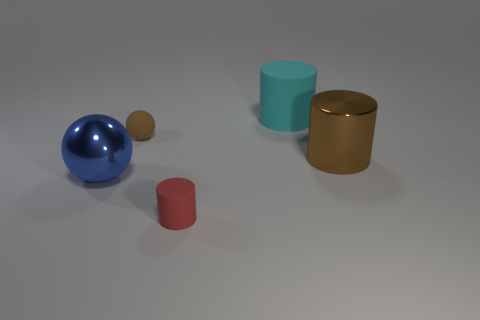There is a big metallic thing in front of the thing that is on the right side of the big matte object; what is its shape?
Offer a terse response. Sphere. How many things are big brown metallic things or things that are behind the small rubber cylinder?
Your answer should be very brief. 4. What number of other things are there of the same color as the large shiny cylinder?
Keep it short and to the point. 1. How many green objects are cylinders or tiny metal cubes?
Give a very brief answer. 0. There is a matte cylinder that is left of the big object that is behind the large brown thing; are there any large rubber cylinders that are left of it?
Your answer should be very brief. No. Is the metallic cylinder the same color as the matte sphere?
Your answer should be compact. Yes. What is the color of the cylinder in front of the shiny object on the left side of the brown ball?
Offer a very short reply. Red. What number of large objects are brown objects or spheres?
Your response must be concise. 2. The large thing that is both on the right side of the rubber sphere and in front of the cyan matte cylinder is what color?
Offer a terse response. Brown. Does the large blue object have the same material as the brown cylinder?
Keep it short and to the point. Yes. 